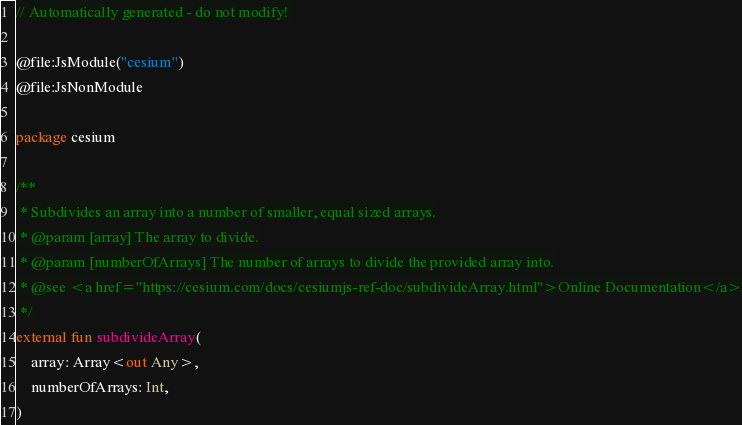Convert code to text. <code><loc_0><loc_0><loc_500><loc_500><_Kotlin_>// Automatically generated - do not modify!

@file:JsModule("cesium")
@file:JsNonModule

package cesium

/**
 * Subdivides an array into a number of smaller, equal sized arrays.
 * @param [array] The array to divide.
 * @param [numberOfArrays] The number of arrays to divide the provided array into.
 * @see <a href="https://cesium.com/docs/cesiumjs-ref-doc/subdivideArray.html">Online Documentation</a>
 */
external fun subdivideArray(
    array: Array<out Any>,
    numberOfArrays: Int,
)
</code> 